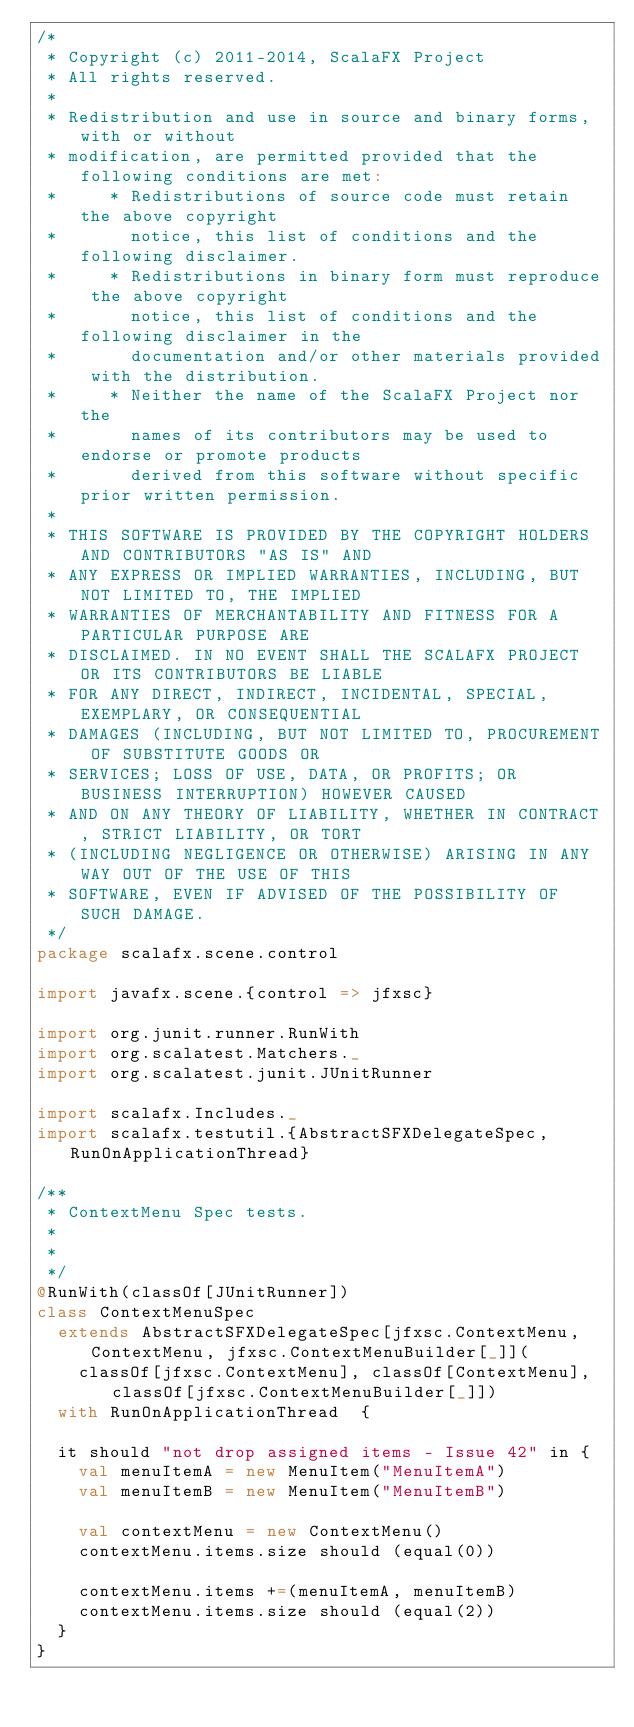<code> <loc_0><loc_0><loc_500><loc_500><_Scala_>/*
 * Copyright (c) 2011-2014, ScalaFX Project
 * All rights reserved.
 *
 * Redistribution and use in source and binary forms, with or without
 * modification, are permitted provided that the following conditions are met:
 *     * Redistributions of source code must retain the above copyright
 *       notice, this list of conditions and the following disclaimer.
 *     * Redistributions in binary form must reproduce the above copyright
 *       notice, this list of conditions and the following disclaimer in the
 *       documentation and/or other materials provided with the distribution.
 *     * Neither the name of the ScalaFX Project nor the
 *       names of its contributors may be used to endorse or promote products
 *       derived from this software without specific prior written permission.
 *
 * THIS SOFTWARE IS PROVIDED BY THE COPYRIGHT HOLDERS AND CONTRIBUTORS "AS IS" AND
 * ANY EXPRESS OR IMPLIED WARRANTIES, INCLUDING, BUT NOT LIMITED TO, THE IMPLIED
 * WARRANTIES OF MERCHANTABILITY AND FITNESS FOR A PARTICULAR PURPOSE ARE
 * DISCLAIMED. IN NO EVENT SHALL THE SCALAFX PROJECT OR ITS CONTRIBUTORS BE LIABLE
 * FOR ANY DIRECT, INDIRECT, INCIDENTAL, SPECIAL, EXEMPLARY, OR CONSEQUENTIAL
 * DAMAGES (INCLUDING, BUT NOT LIMITED TO, PROCUREMENT OF SUBSTITUTE GOODS OR
 * SERVICES; LOSS OF USE, DATA, OR PROFITS; OR BUSINESS INTERRUPTION) HOWEVER CAUSED
 * AND ON ANY THEORY OF LIABILITY, WHETHER IN CONTRACT, STRICT LIABILITY, OR TORT
 * (INCLUDING NEGLIGENCE OR OTHERWISE) ARISING IN ANY WAY OUT OF THE USE OF THIS
 * SOFTWARE, EVEN IF ADVISED OF THE POSSIBILITY OF SUCH DAMAGE.
 */
package scalafx.scene.control

import javafx.scene.{control => jfxsc}

import org.junit.runner.RunWith
import org.scalatest.Matchers._
import org.scalatest.junit.JUnitRunner

import scalafx.Includes._
import scalafx.testutil.{AbstractSFXDelegateSpec, RunOnApplicationThread}

/**
 * ContextMenu Spec tests.
 *
 *
 */
@RunWith(classOf[JUnitRunner])
class ContextMenuSpec
  extends AbstractSFXDelegateSpec[jfxsc.ContextMenu, ContextMenu, jfxsc.ContextMenuBuilder[_]](
    classOf[jfxsc.ContextMenu], classOf[ContextMenu], classOf[jfxsc.ContextMenuBuilder[_]])
  with RunOnApplicationThread  {

  it should "not drop assigned items - Issue 42" in {
    val menuItemA = new MenuItem("MenuItemA")
    val menuItemB = new MenuItem("MenuItemB")

    val contextMenu = new ContextMenu()
    contextMenu.items.size should (equal(0))

    contextMenu.items +=(menuItemA, menuItemB)
    contextMenu.items.size should (equal(2))
  }
}</code> 